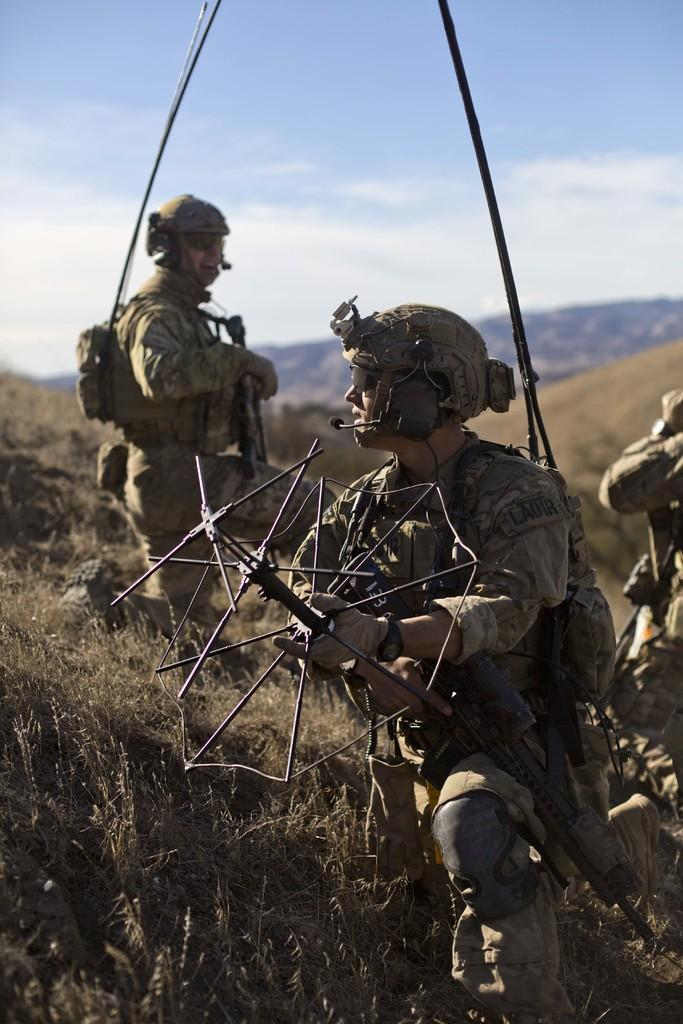What is the primary location of the people in the image? The people are on the ground in the image. What type of vegetation is present in the image? There is dry grass in the image. What can be seen in the distance in the image? There are hills in the background of the image. What is visible in the sky in the image? The sky is visible in the background of the image, and there are clouds present. How many cattle are grazing in the spoon in the image? There are no cattle or spoons present in the image. 